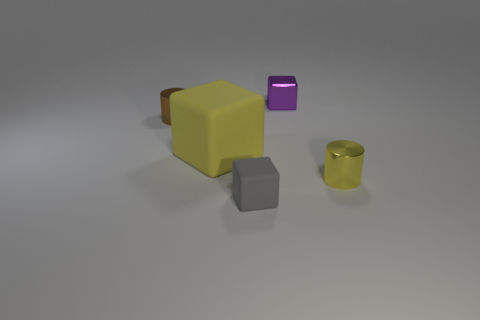Is there anything else that has the same size as the yellow rubber thing?
Give a very brief answer. No. What number of other things are the same shape as the brown metallic object?
Offer a terse response. 1. There is a yellow cylinder that is on the right side of the small brown metal cylinder; what is it made of?
Ensure brevity in your answer.  Metal. Is the number of big cubes in front of the tiny purple thing less than the number of tiny purple cubes?
Your answer should be compact. No. Is the shape of the purple shiny object the same as the gray thing?
Make the answer very short. Yes. Is there anything else that is the same shape as the big yellow matte thing?
Ensure brevity in your answer.  Yes. Are any yellow cylinders visible?
Give a very brief answer. Yes. Is the shape of the small yellow object the same as the yellow thing that is left of the small matte thing?
Your response must be concise. No. What material is the yellow object left of the shiny cylinder on the right side of the tiny purple block made of?
Offer a terse response. Rubber. What color is the small rubber object?
Make the answer very short. Gray. 